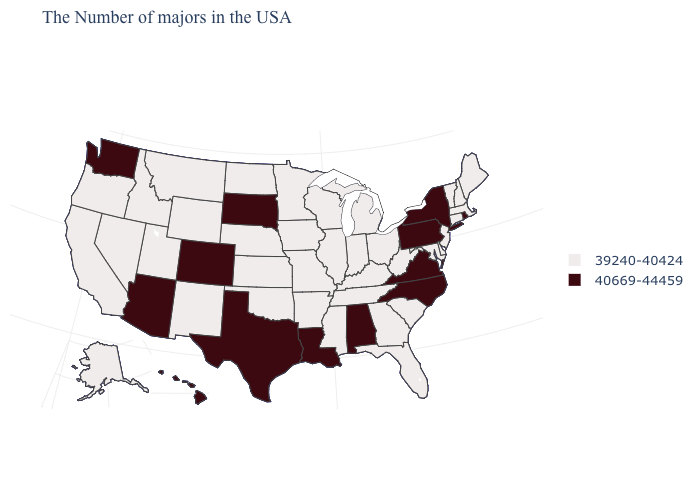Which states have the lowest value in the South?
Keep it brief. Delaware, Maryland, South Carolina, West Virginia, Florida, Georgia, Kentucky, Tennessee, Mississippi, Arkansas, Oklahoma. Is the legend a continuous bar?
Give a very brief answer. No. Name the states that have a value in the range 39240-40424?
Keep it brief. Maine, Massachusetts, New Hampshire, Vermont, Connecticut, New Jersey, Delaware, Maryland, South Carolina, West Virginia, Ohio, Florida, Georgia, Michigan, Kentucky, Indiana, Tennessee, Wisconsin, Illinois, Mississippi, Missouri, Arkansas, Minnesota, Iowa, Kansas, Nebraska, Oklahoma, North Dakota, Wyoming, New Mexico, Utah, Montana, Idaho, Nevada, California, Oregon, Alaska. Name the states that have a value in the range 39240-40424?
Answer briefly. Maine, Massachusetts, New Hampshire, Vermont, Connecticut, New Jersey, Delaware, Maryland, South Carolina, West Virginia, Ohio, Florida, Georgia, Michigan, Kentucky, Indiana, Tennessee, Wisconsin, Illinois, Mississippi, Missouri, Arkansas, Minnesota, Iowa, Kansas, Nebraska, Oklahoma, North Dakota, Wyoming, New Mexico, Utah, Montana, Idaho, Nevada, California, Oregon, Alaska. Which states hav the highest value in the West?
Keep it brief. Colorado, Arizona, Washington, Hawaii. What is the value of Missouri?
Quick response, please. 39240-40424. What is the highest value in the Northeast ?
Short answer required. 40669-44459. What is the value of South Dakota?
Answer briefly. 40669-44459. Does Alabama have the lowest value in the USA?
Give a very brief answer. No. What is the value of Delaware?
Keep it brief. 39240-40424. Name the states that have a value in the range 40669-44459?
Concise answer only. Rhode Island, New York, Pennsylvania, Virginia, North Carolina, Alabama, Louisiana, Texas, South Dakota, Colorado, Arizona, Washington, Hawaii. Among the states that border Minnesota , does South Dakota have the highest value?
Quick response, please. Yes. Does the first symbol in the legend represent the smallest category?
Give a very brief answer. Yes. What is the highest value in states that border Vermont?
Concise answer only. 40669-44459. Does the first symbol in the legend represent the smallest category?
Short answer required. Yes. 